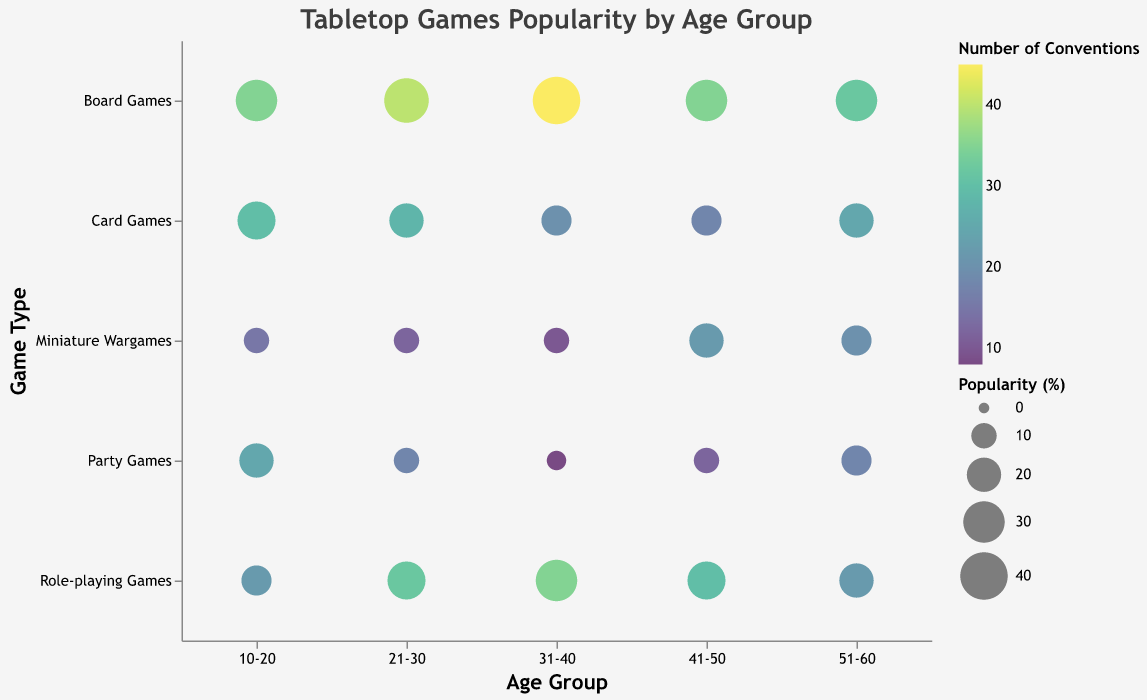What's the title of the figure? The title is displayed at the top of the figure as "Tabletop Games Popularity by Age Group".
Answer: Tabletop Games Popularity by Age Group Which age group has the highest percentage for Board Games? By looking at the size of the bubbles corresponding to Board Games in each age group, the largest bubble (indicating the highest percentage) is found in age group 31-40.
Answer: 31-40 How many conventions attended by people aged 41-50 for Miniature Wargames? By checking the color legend corresponding to the Number of Conventions and locating the bubble for Miniature Wargames in the 41-50 age group, the value is indicated as 22.
Answer: 22 What is the average percentage of Role-playing Games for all age groups? Identify and sum the Role-playing Games percentages across all age groups (15, 25, 30, 25, 20). Then, divide by the number of age groups (5). So, (15+25+30+25+20)/5 = 23%.
Answer: 23% Which type of tabletop games is played equally frequently (in terms of percentage) in two different age groups? Look for a game type where the sizes of the bubbles (indicating percentage) are the same for two age groups. Party Games have a 10% bubble for both the 21-30 and 41-50 age groups.
Answer: Party Games Which age group has the widest variety in Tabletop Game Types, according to the Number of Conventions? The color legend indicates the Number of Conventions. The age group with the largest range in color (from the minimum to maximum Number of Conventions) is 10-20, ranging from 15 (Miniature Wargames) to 35 (Board Games).
Answer: 10-20 In the 51-60 age group, which game type is the least popular? By examining the bubbles' sizes representing the percentage within the 51-60 category, Role-playing Games, Miniature Wargames, and Party Games are all equally the least popular at 15%.
Answer: Role-playing Games, Miniature Wargames, Party Games Compare the popularity of Card Games between the youngest and the oldest age groups. For Card Games, compare the sizes of the 10-20 and 51-60 bubbles. The 10-20 age group has a 25% bubble for Card Games, whereas the 51-60 has a 20% bubble. Thus, Card Games are more popular in the 10-20 age group.
Answer: 10-20 What is the total number of conventions attended by people aged 21-30 across all game types? Sum the Number of Conventions for each game type within the 21-30 age group: 28 (Card Games) + 40 (Board Games) + 32 (Role-playing Games) + 12 (Miniature Wargames) + 18 (Party Games) = 130.
Answer: 130 